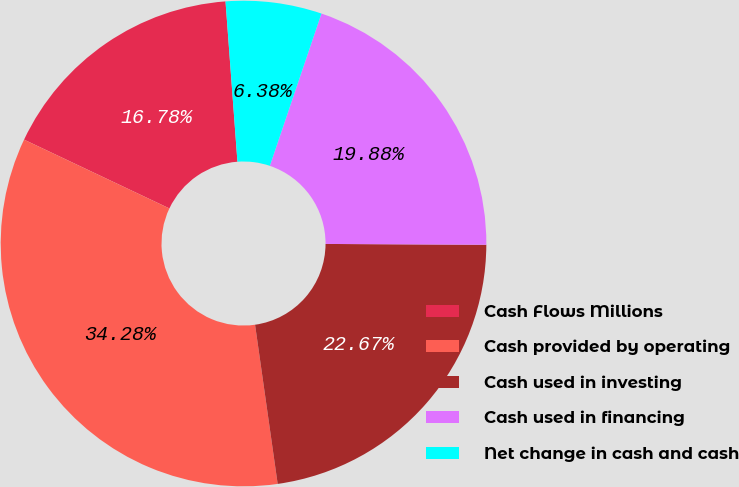Convert chart to OTSL. <chart><loc_0><loc_0><loc_500><loc_500><pie_chart><fcel>Cash Flows Millions<fcel>Cash provided by operating<fcel>Cash used in investing<fcel>Cash used in financing<fcel>Net change in cash and cash<nl><fcel>16.78%<fcel>34.28%<fcel>22.67%<fcel>19.88%<fcel>6.38%<nl></chart> 